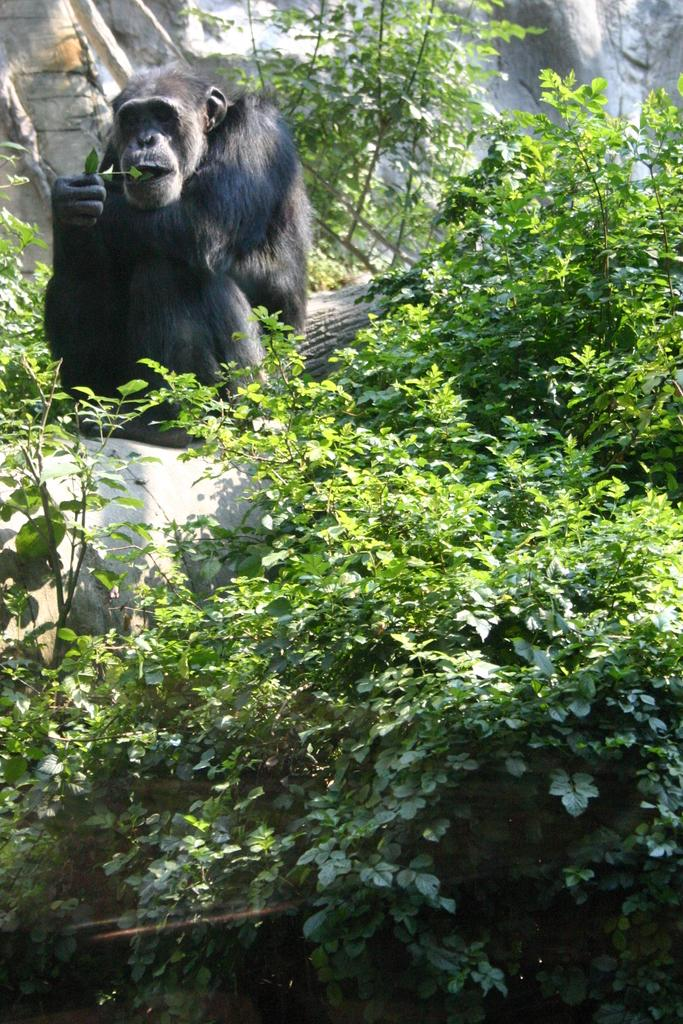What type of animal is in the picture? There is a chimpanzee in the picture. What else can be seen in the picture besides the chimpanzee? There are plants in the picture. Where is the nearest shop to the chimpanzee in the picture? There is no shop present in the image, as it only features a chimpanzee and plants. 